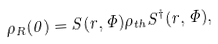Convert formula to latex. <formula><loc_0><loc_0><loc_500><loc_500>\rho _ { R } ( 0 ) = S ( r , \Phi ) \rho _ { t h } S ^ { \dagger } ( r , \Phi ) ,</formula> 